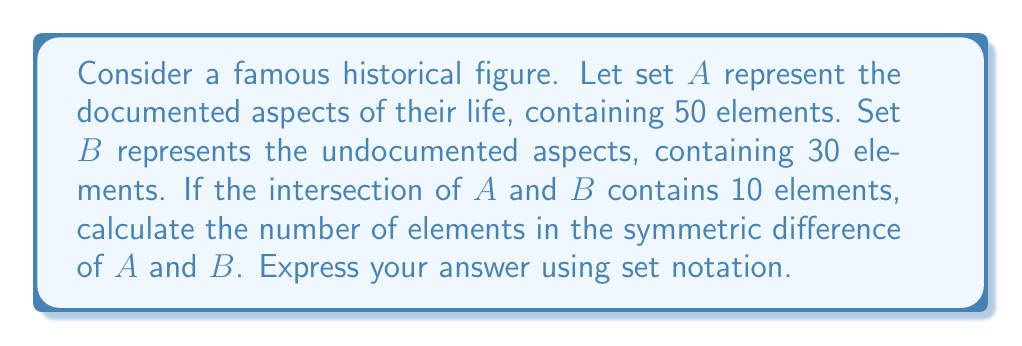Provide a solution to this math problem. To solve this problem, we need to understand the concept of symmetric difference and apply set theory principles:

1. The symmetric difference of two sets $A$ and $B$, denoted as $A \triangle B$, is defined as the set of elements that are in either $A$ or $B$, but not in both.

2. Mathematically, this can be expressed as: $A \triangle B = (A \setminus B) \cup (B \setminus A)$

3. We're given:
   - $|A| = 50$ (documented aspects)
   - $|B| = 30$ (undocumented aspects)
   - $|A \cap B| = 10$ (intersection)

4. To find the symmetric difference, we need to:
   a) Find elements unique to $A$: $|A \setminus B| = |A| - |A \cap B| = 50 - 10 = 40$
   b) Find elements unique to $B$: $|B \setminus A| = |B| - |A \cap B| = 30 - 10 = 20$

5. The symmetric difference is the union of these unique elements:
   $|A \triangle B| = |A \setminus B| + |B \setminus A| = 40 + 20 = 60$

Therefore, the symmetric difference contains 60 elements, representing aspects of the historical figure's life that are either documented or undocumented, but not both.
Answer: $|A \triangle B| = 60$ 